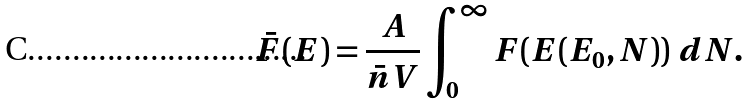<formula> <loc_0><loc_0><loc_500><loc_500>\bar { F } ( E ) = \frac { A } { \bar { n } V } \int _ { 0 } ^ { \infty } F ( E ( E _ { 0 } , N ) ) \ d N .</formula> 